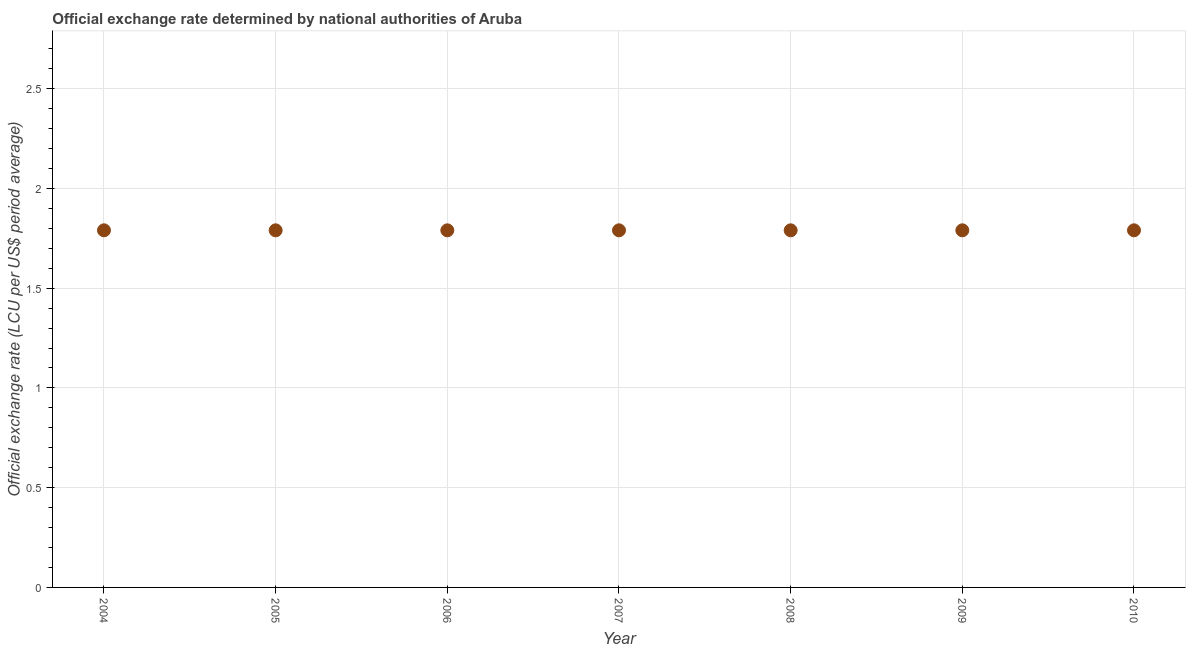What is the official exchange rate in 2009?
Provide a short and direct response. 1.79. Across all years, what is the maximum official exchange rate?
Give a very brief answer. 1.79. Across all years, what is the minimum official exchange rate?
Offer a very short reply. 1.79. In which year was the official exchange rate maximum?
Your response must be concise. 2004. What is the sum of the official exchange rate?
Keep it short and to the point. 12.53. What is the difference between the official exchange rate in 2005 and 2009?
Your response must be concise. 0. What is the average official exchange rate per year?
Your response must be concise. 1.79. What is the median official exchange rate?
Make the answer very short. 1.79. Is the difference between the official exchange rate in 2006 and 2010 greater than the difference between any two years?
Your answer should be very brief. Yes. What is the difference between the highest and the second highest official exchange rate?
Provide a succinct answer. 0. What is the difference between the highest and the lowest official exchange rate?
Provide a succinct answer. 0. How many years are there in the graph?
Provide a short and direct response. 7. What is the difference between two consecutive major ticks on the Y-axis?
Keep it short and to the point. 0.5. Are the values on the major ticks of Y-axis written in scientific E-notation?
Provide a short and direct response. No. Does the graph contain any zero values?
Offer a terse response. No. Does the graph contain grids?
Offer a terse response. Yes. What is the title of the graph?
Provide a short and direct response. Official exchange rate determined by national authorities of Aruba. What is the label or title of the Y-axis?
Ensure brevity in your answer.  Official exchange rate (LCU per US$ period average). What is the Official exchange rate (LCU per US$ period average) in 2004?
Your answer should be compact. 1.79. What is the Official exchange rate (LCU per US$ period average) in 2005?
Offer a terse response. 1.79. What is the Official exchange rate (LCU per US$ period average) in 2006?
Provide a succinct answer. 1.79. What is the Official exchange rate (LCU per US$ period average) in 2007?
Make the answer very short. 1.79. What is the Official exchange rate (LCU per US$ period average) in 2008?
Your answer should be very brief. 1.79. What is the Official exchange rate (LCU per US$ period average) in 2009?
Provide a succinct answer. 1.79. What is the Official exchange rate (LCU per US$ period average) in 2010?
Provide a succinct answer. 1.79. What is the difference between the Official exchange rate (LCU per US$ period average) in 2004 and 2005?
Your response must be concise. 0. What is the difference between the Official exchange rate (LCU per US$ period average) in 2004 and 2008?
Ensure brevity in your answer.  0. What is the difference between the Official exchange rate (LCU per US$ period average) in 2004 and 2009?
Your answer should be compact. 0. What is the difference between the Official exchange rate (LCU per US$ period average) in 2004 and 2010?
Offer a very short reply. 0. What is the difference between the Official exchange rate (LCU per US$ period average) in 2005 and 2006?
Offer a very short reply. 0. What is the difference between the Official exchange rate (LCU per US$ period average) in 2005 and 2007?
Your response must be concise. 0. What is the difference between the Official exchange rate (LCU per US$ period average) in 2005 and 2008?
Your response must be concise. 0. What is the difference between the Official exchange rate (LCU per US$ period average) in 2005 and 2009?
Ensure brevity in your answer.  0. What is the difference between the Official exchange rate (LCU per US$ period average) in 2005 and 2010?
Ensure brevity in your answer.  0. What is the difference between the Official exchange rate (LCU per US$ period average) in 2006 and 2008?
Offer a terse response. 0. What is the difference between the Official exchange rate (LCU per US$ period average) in 2006 and 2009?
Your answer should be very brief. 0. What is the difference between the Official exchange rate (LCU per US$ period average) in 2006 and 2010?
Your answer should be very brief. 0. What is the difference between the Official exchange rate (LCU per US$ period average) in 2007 and 2008?
Your answer should be very brief. 0. What is the difference between the Official exchange rate (LCU per US$ period average) in 2007 and 2009?
Keep it short and to the point. 0. What is the difference between the Official exchange rate (LCU per US$ period average) in 2007 and 2010?
Keep it short and to the point. 0. What is the difference between the Official exchange rate (LCU per US$ period average) in 2008 and 2010?
Keep it short and to the point. 0. What is the difference between the Official exchange rate (LCU per US$ period average) in 2009 and 2010?
Ensure brevity in your answer.  0. What is the ratio of the Official exchange rate (LCU per US$ period average) in 2004 to that in 2005?
Keep it short and to the point. 1. What is the ratio of the Official exchange rate (LCU per US$ period average) in 2004 to that in 2007?
Provide a succinct answer. 1. What is the ratio of the Official exchange rate (LCU per US$ period average) in 2004 to that in 2008?
Ensure brevity in your answer.  1. What is the ratio of the Official exchange rate (LCU per US$ period average) in 2005 to that in 2006?
Provide a succinct answer. 1. What is the ratio of the Official exchange rate (LCU per US$ period average) in 2005 to that in 2008?
Ensure brevity in your answer.  1. What is the ratio of the Official exchange rate (LCU per US$ period average) in 2005 to that in 2009?
Provide a succinct answer. 1. What is the ratio of the Official exchange rate (LCU per US$ period average) in 2005 to that in 2010?
Offer a very short reply. 1. What is the ratio of the Official exchange rate (LCU per US$ period average) in 2006 to that in 2009?
Offer a very short reply. 1. What is the ratio of the Official exchange rate (LCU per US$ period average) in 2006 to that in 2010?
Keep it short and to the point. 1. What is the ratio of the Official exchange rate (LCU per US$ period average) in 2007 to that in 2008?
Give a very brief answer. 1. What is the ratio of the Official exchange rate (LCU per US$ period average) in 2008 to that in 2009?
Ensure brevity in your answer.  1. What is the ratio of the Official exchange rate (LCU per US$ period average) in 2008 to that in 2010?
Make the answer very short. 1. What is the ratio of the Official exchange rate (LCU per US$ period average) in 2009 to that in 2010?
Your answer should be compact. 1. 